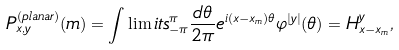<formula> <loc_0><loc_0><loc_500><loc_500>P ^ { ( p l a n a r ) } _ { x , y } ( m ) = \int \lim i t s _ { - \pi } ^ { \pi } \frac { d \theta } { 2 \pi } e ^ { i ( x - x _ { m } ) \theta } \varphi ^ { | y | } ( \theta ) = H ^ { y } _ { x - x _ { m } } ,</formula> 